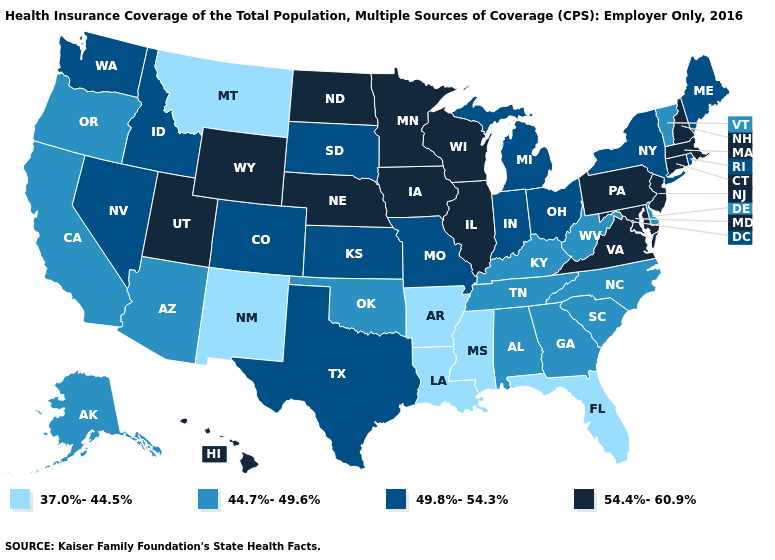Name the states that have a value in the range 49.8%-54.3%?
Be succinct. Colorado, Idaho, Indiana, Kansas, Maine, Michigan, Missouri, Nevada, New York, Ohio, Rhode Island, South Dakota, Texas, Washington. Among the states that border California , which have the lowest value?
Write a very short answer. Arizona, Oregon. Does the map have missing data?
Answer briefly. No. Does Arkansas have the same value as Ohio?
Concise answer only. No. Name the states that have a value in the range 37.0%-44.5%?
Concise answer only. Arkansas, Florida, Louisiana, Mississippi, Montana, New Mexico. Does Maryland have the highest value in the South?
Be succinct. Yes. What is the lowest value in the USA?
Be succinct. 37.0%-44.5%. Name the states that have a value in the range 54.4%-60.9%?
Be succinct. Connecticut, Hawaii, Illinois, Iowa, Maryland, Massachusetts, Minnesota, Nebraska, New Hampshire, New Jersey, North Dakota, Pennsylvania, Utah, Virginia, Wisconsin, Wyoming. What is the value of Michigan?
Be succinct. 49.8%-54.3%. What is the value of Georgia?
Keep it brief. 44.7%-49.6%. Name the states that have a value in the range 54.4%-60.9%?
Short answer required. Connecticut, Hawaii, Illinois, Iowa, Maryland, Massachusetts, Minnesota, Nebraska, New Hampshire, New Jersey, North Dakota, Pennsylvania, Utah, Virginia, Wisconsin, Wyoming. Among the states that border Oklahoma , which have the highest value?
Keep it brief. Colorado, Kansas, Missouri, Texas. Is the legend a continuous bar?
Keep it brief. No. Which states have the highest value in the USA?
Be succinct. Connecticut, Hawaii, Illinois, Iowa, Maryland, Massachusetts, Minnesota, Nebraska, New Hampshire, New Jersey, North Dakota, Pennsylvania, Utah, Virginia, Wisconsin, Wyoming. Which states have the lowest value in the West?
Answer briefly. Montana, New Mexico. 